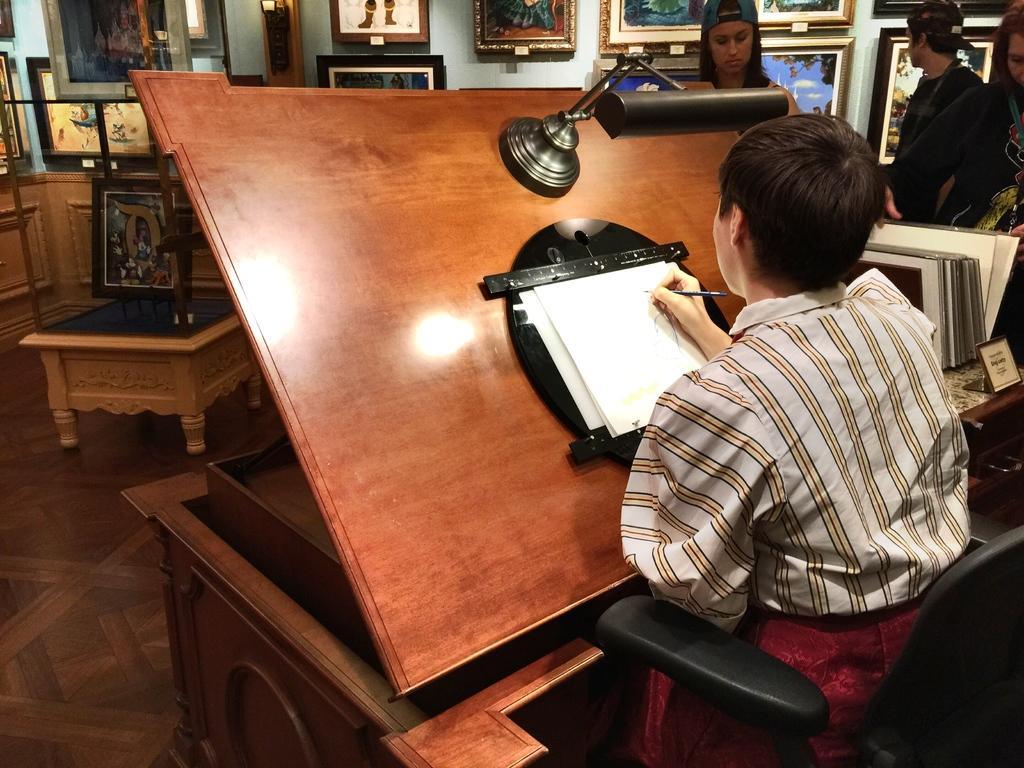Can you describe this image briefly? In this picture we can see a person sitting on the chair and drawing something on the paper. And here we can see three persons standing on the floor. On the background there is a wall. And there are many frames and this is the floor. 